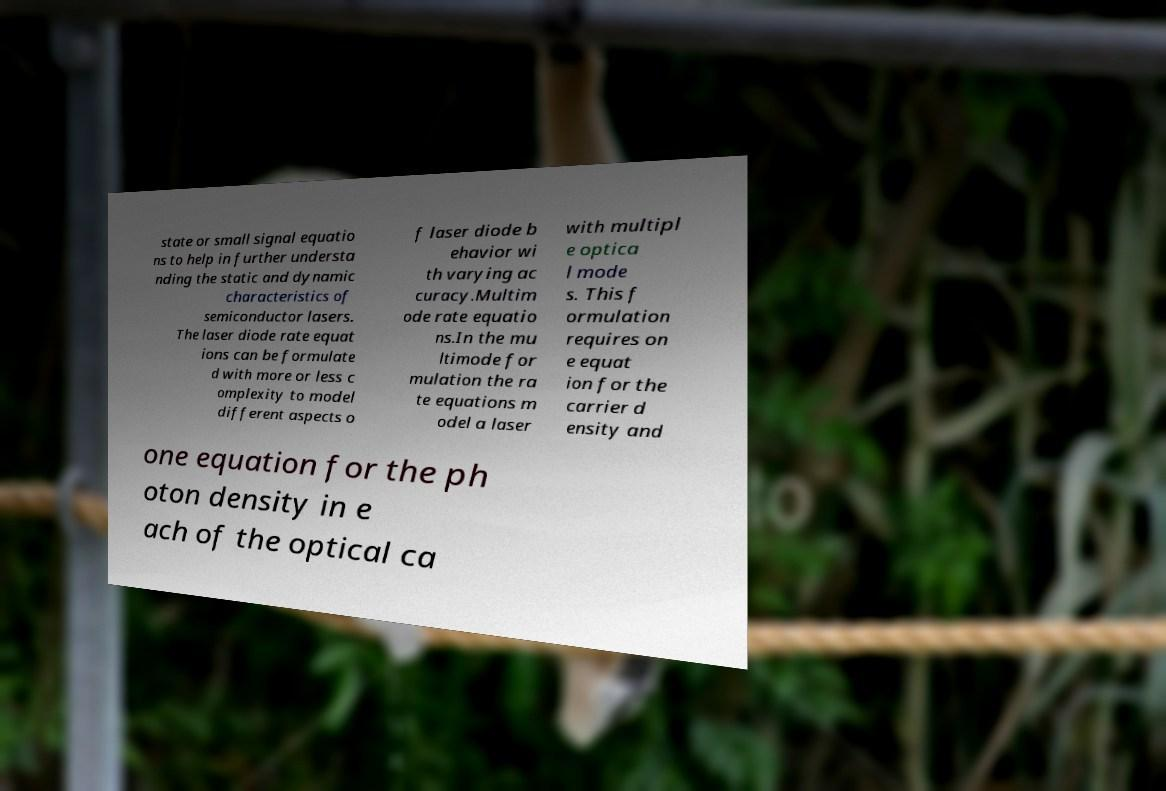For documentation purposes, I need the text within this image transcribed. Could you provide that? state or small signal equatio ns to help in further understa nding the static and dynamic characteristics of semiconductor lasers. The laser diode rate equat ions can be formulate d with more or less c omplexity to model different aspects o f laser diode b ehavior wi th varying ac curacy.Multim ode rate equatio ns.In the mu ltimode for mulation the ra te equations m odel a laser with multipl e optica l mode s. This f ormulation requires on e equat ion for the carrier d ensity and one equation for the ph oton density in e ach of the optical ca 